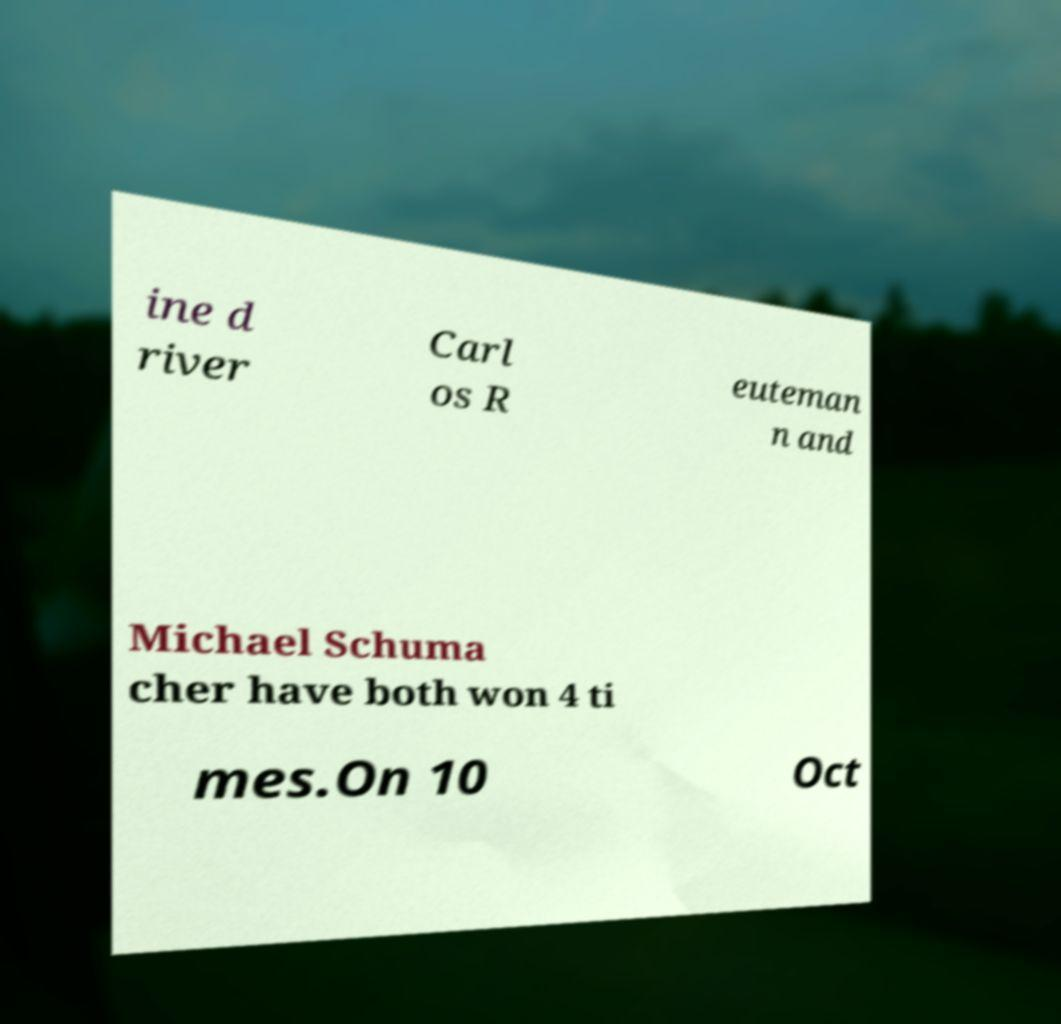Could you assist in decoding the text presented in this image and type it out clearly? ine d river Carl os R euteman n and Michael Schuma cher have both won 4 ti mes.On 10 Oct 